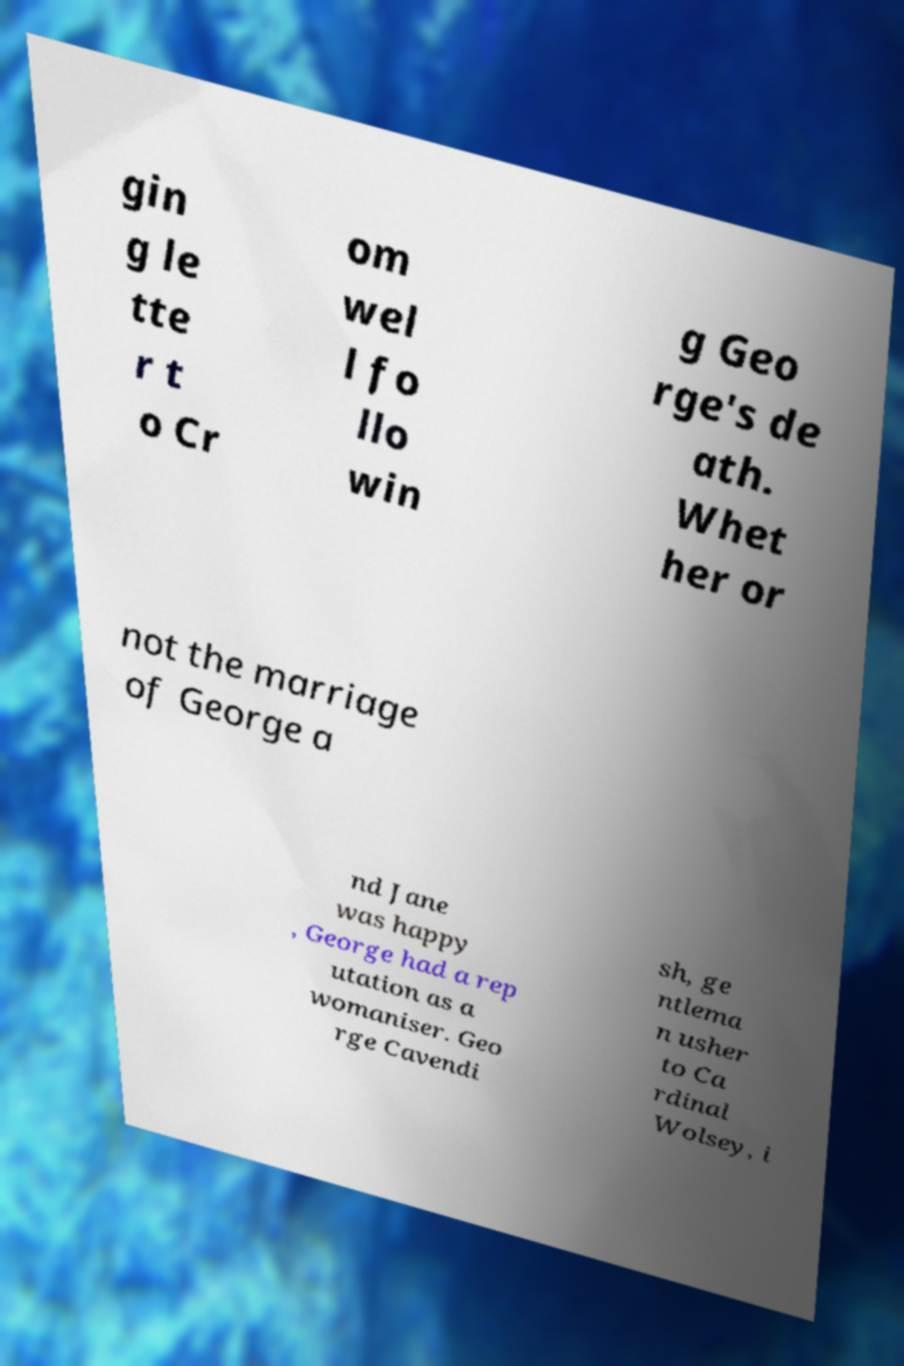What messages or text are displayed in this image? I need them in a readable, typed format. gin g le tte r t o Cr om wel l fo llo win g Geo rge's de ath. Whet her or not the marriage of George a nd Jane was happy , George had a rep utation as a womaniser. Geo rge Cavendi sh, ge ntlema n usher to Ca rdinal Wolsey, i 